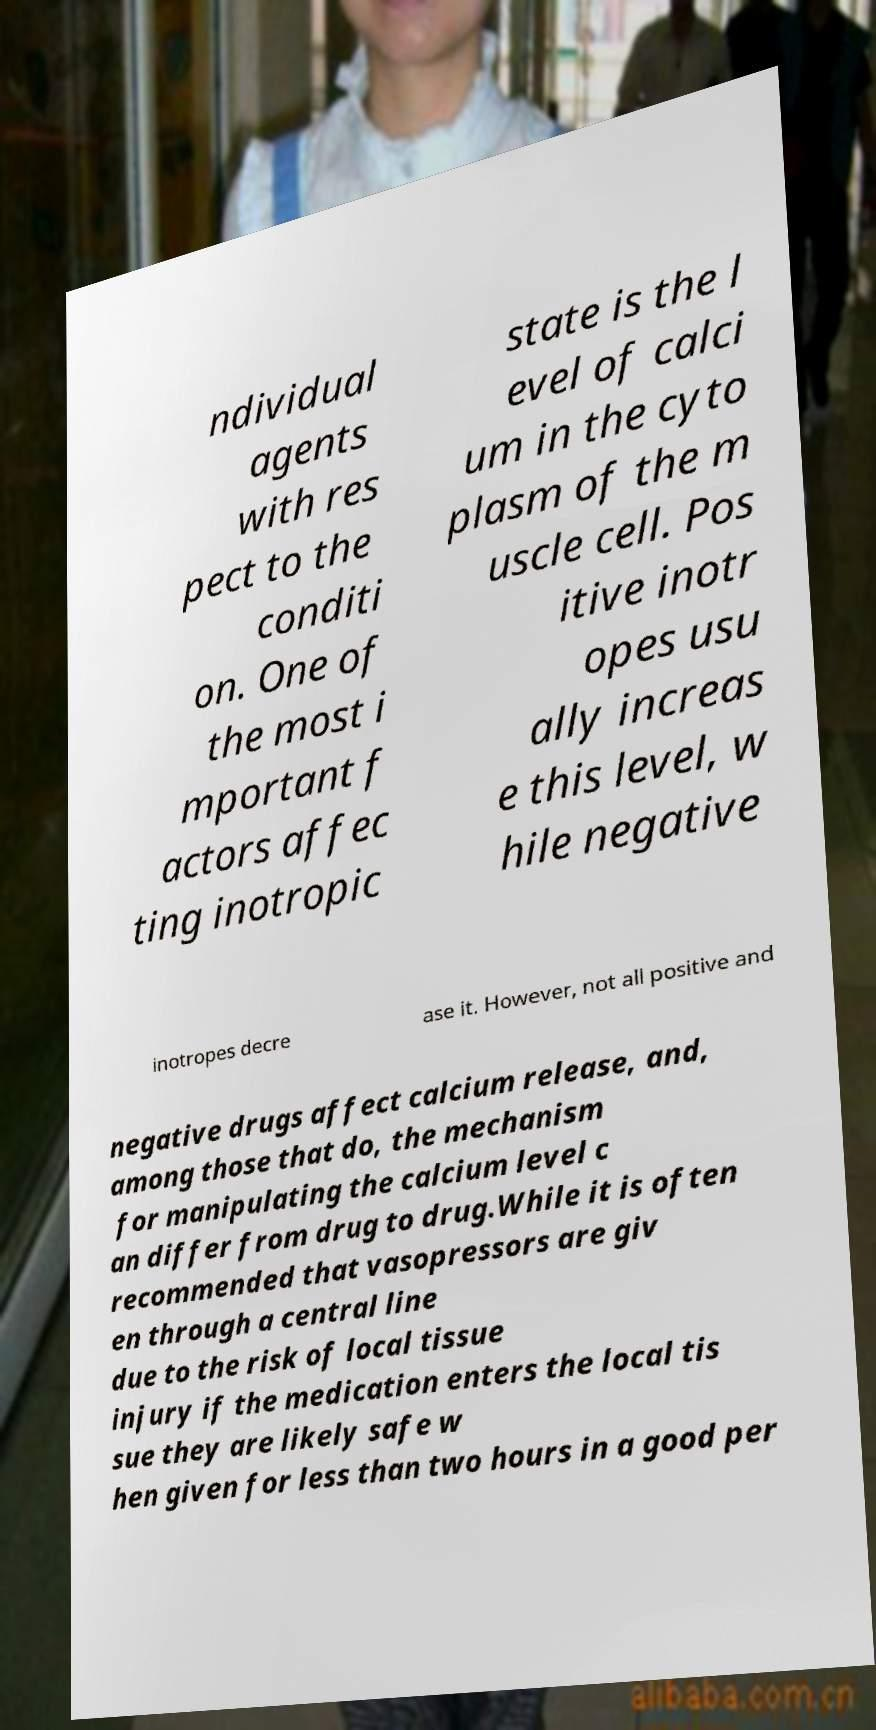What messages or text are displayed in this image? I need them in a readable, typed format. ndividual agents with res pect to the conditi on. One of the most i mportant f actors affec ting inotropic state is the l evel of calci um in the cyto plasm of the m uscle cell. Pos itive inotr opes usu ally increas e this level, w hile negative inotropes decre ase it. However, not all positive and negative drugs affect calcium release, and, among those that do, the mechanism for manipulating the calcium level c an differ from drug to drug.While it is often recommended that vasopressors are giv en through a central line due to the risk of local tissue injury if the medication enters the local tis sue they are likely safe w hen given for less than two hours in a good per 